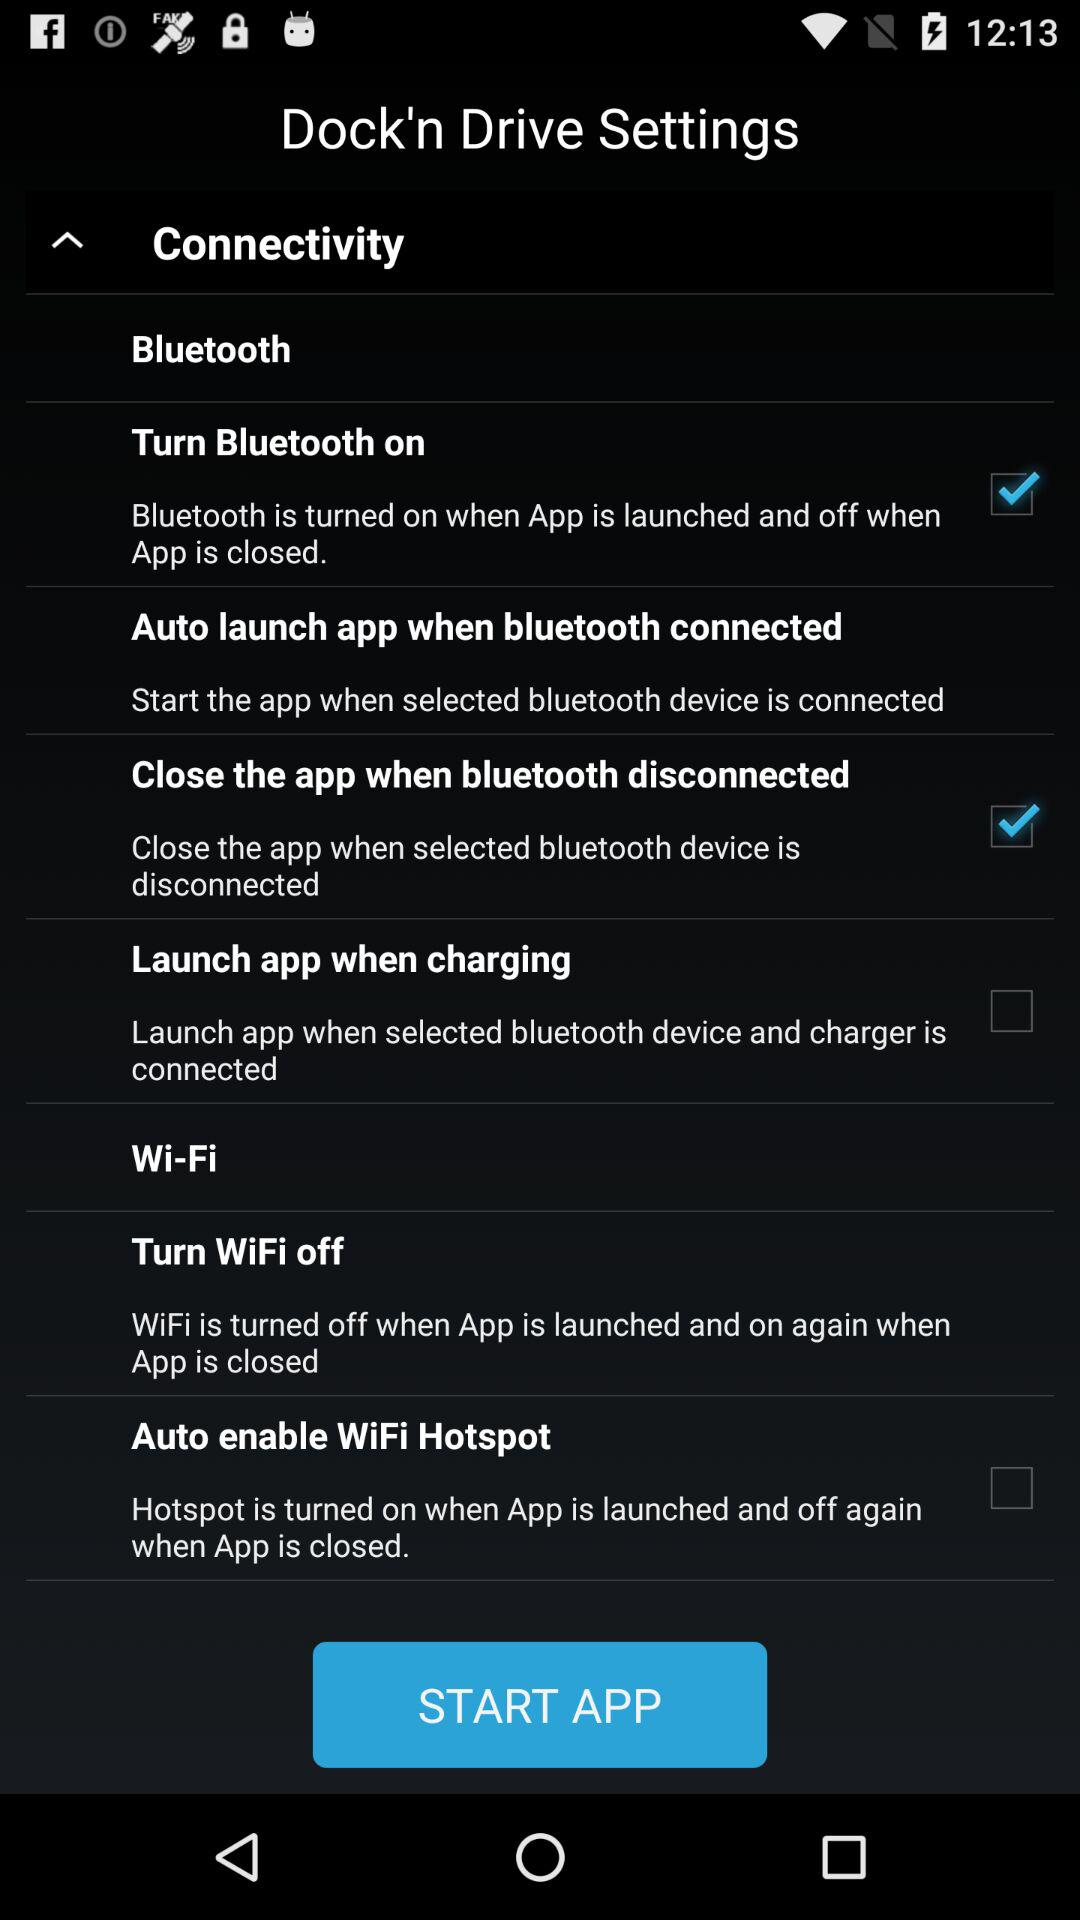Which settings are unchecked? The unchecked settings are "Launch app when charging" and "Auto enable WiFi Hotspot". 